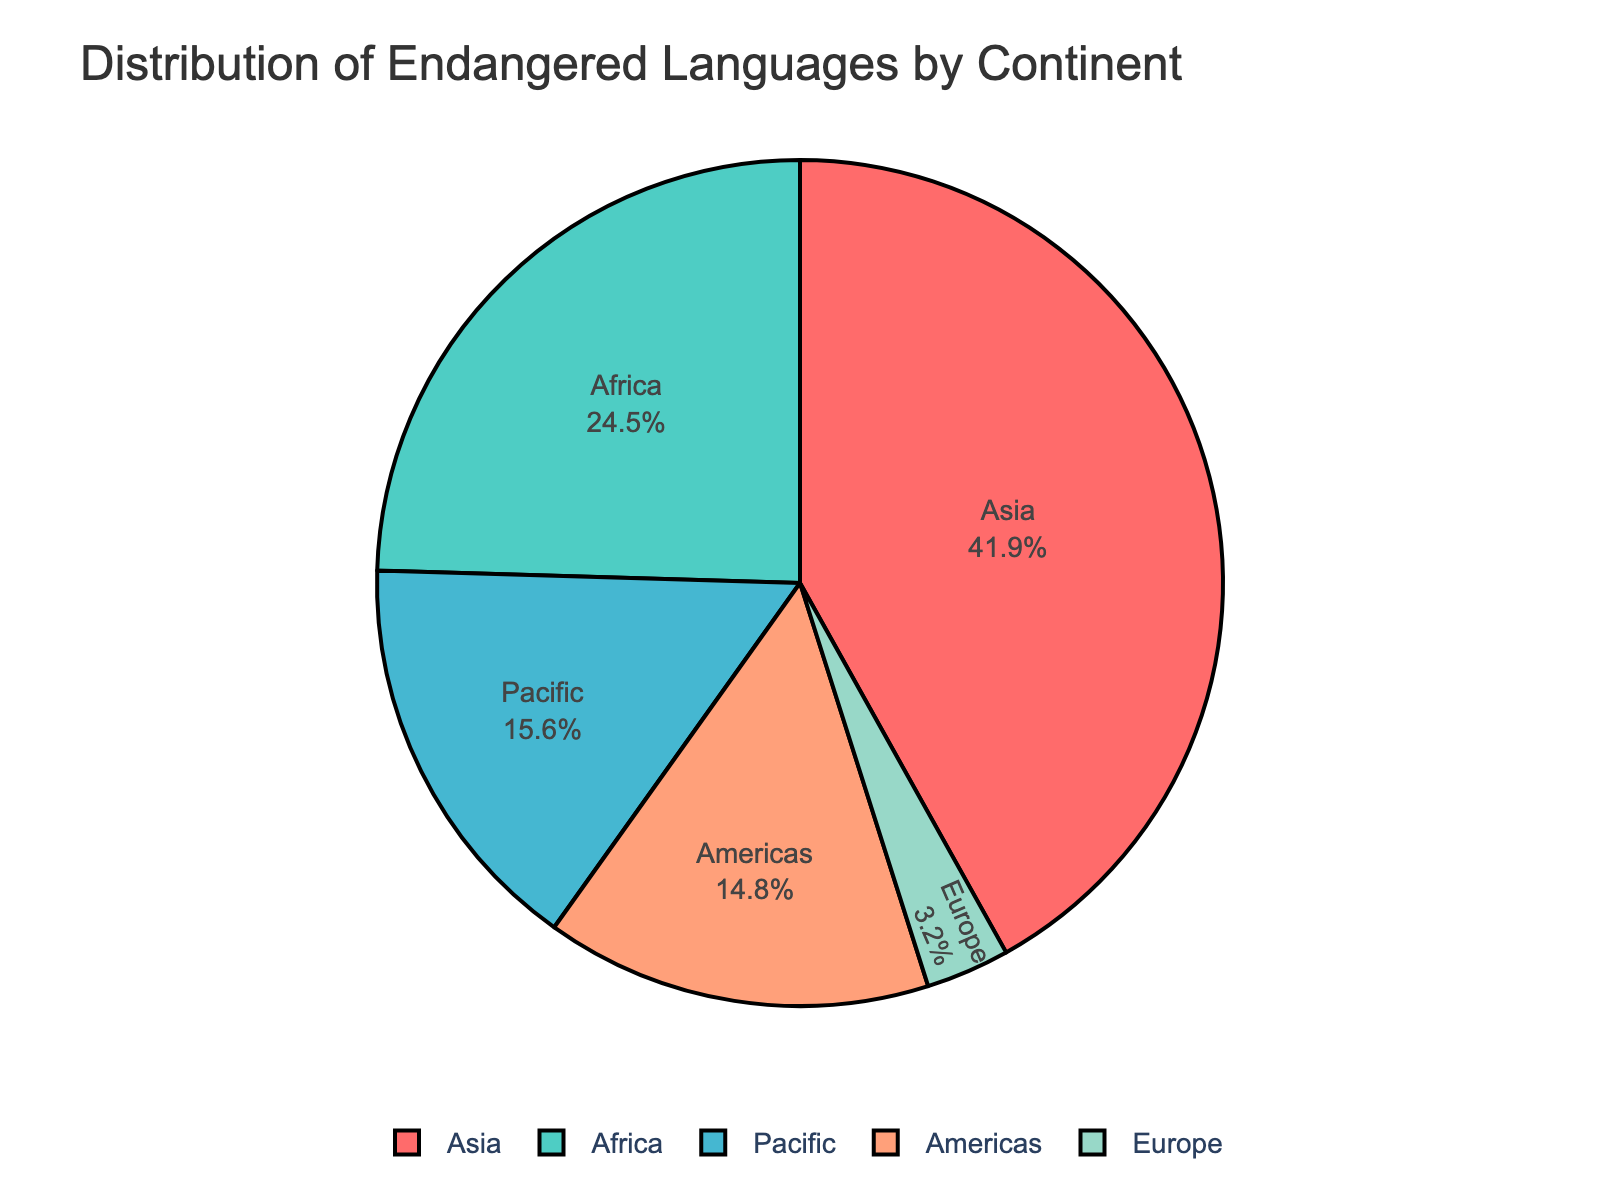what is the continent with the highest number of endangered languages? By visually identifying the largest segment in the pie chart, we see that Asia has the highest proportion. Checking the segment labels confirms Asia has 1,257 languages, the highest of all continents.
Answer: Asia Which continent has fewer endangered languages, Europe or the Americas? By visually comparing the two segments, we observe that Europe's segment is smaller. Confirming with labels, Europe has 96 languages, whereas the Americas have 443.
Answer: Europe By what percentage does Africa exceed the Pacific in terms of endangered languages? Africa has 736 endangered languages and the Pacific has 468. The difference is 736 - 468 = 268. To find the percentage: (268 / 468) * 100 ≈ 57.26%.
Answer: 57.26% What is the combined total of endangered languages in Africa and the Americas? Adding the numbers for Africa (736) and the Americas (443): 736 + 443 = 1,179.
Answer: 1,179 Which continents together contain more than 75% of the total endangered languages? Adding the proportions of Asia (37.48%), Africa (21.94%), and the Pacific (13.95%) gives: 37.48 + 21.94 + 13.95 = 73.37%. Adding just Europe (2.86%) to this brings the total to 76.23%, confirming it's Asia, Africa, and Pacific.
Answer: Asia, Africa, Pacific What fraction of the total do European endangered languages represent? Europe has 96 endangered languages. The total number of endangered languages is 1257 + 736 + 468 + 443 + 96 = 3000. Thus, the fraction is 96 / 3000 = 1/31.25 or approximately 3.2%.
Answer: 3.2% How many more endangered languages does Asia have compared to Europe? Subtract the number of endangered languages in Europe (96) from Asia’s total (1257): 1257 - 96 = 1161.
Answer: 1161 